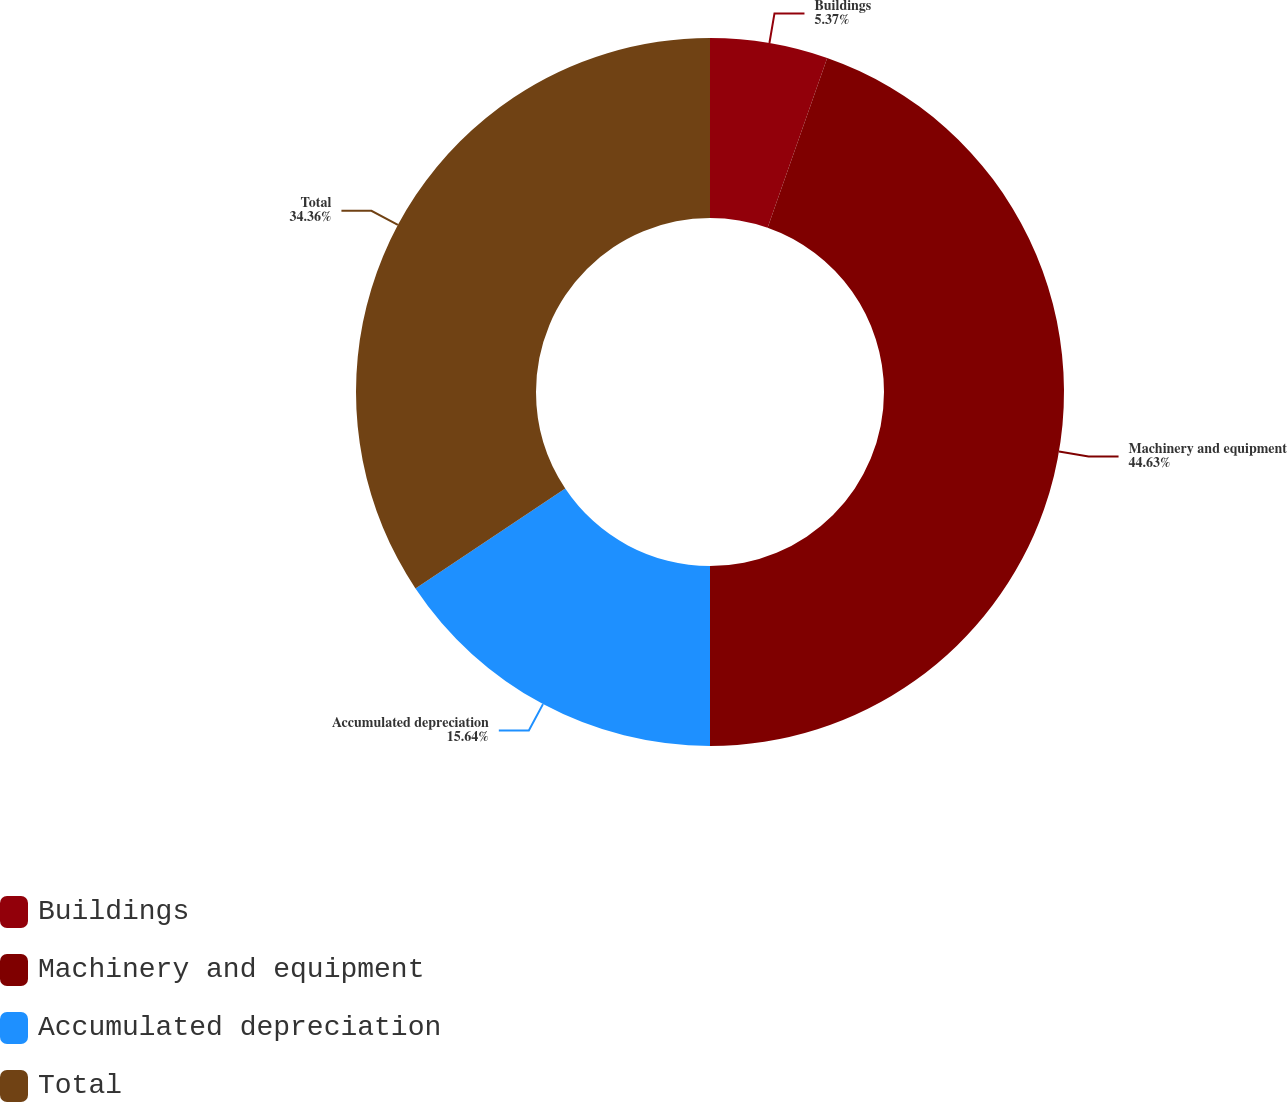Convert chart to OTSL. <chart><loc_0><loc_0><loc_500><loc_500><pie_chart><fcel>Buildings<fcel>Machinery and equipment<fcel>Accumulated depreciation<fcel>Total<nl><fcel>5.37%<fcel>44.63%<fcel>15.64%<fcel>34.36%<nl></chart> 